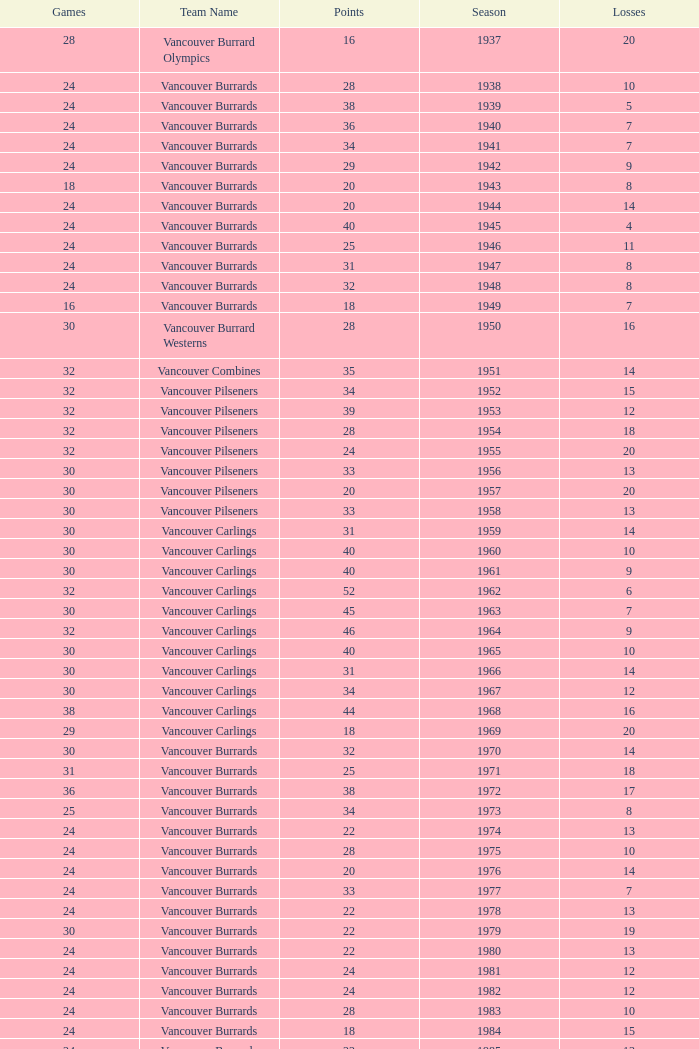What's the sum of points for the 1963 season when there are more than 30 games? None. 